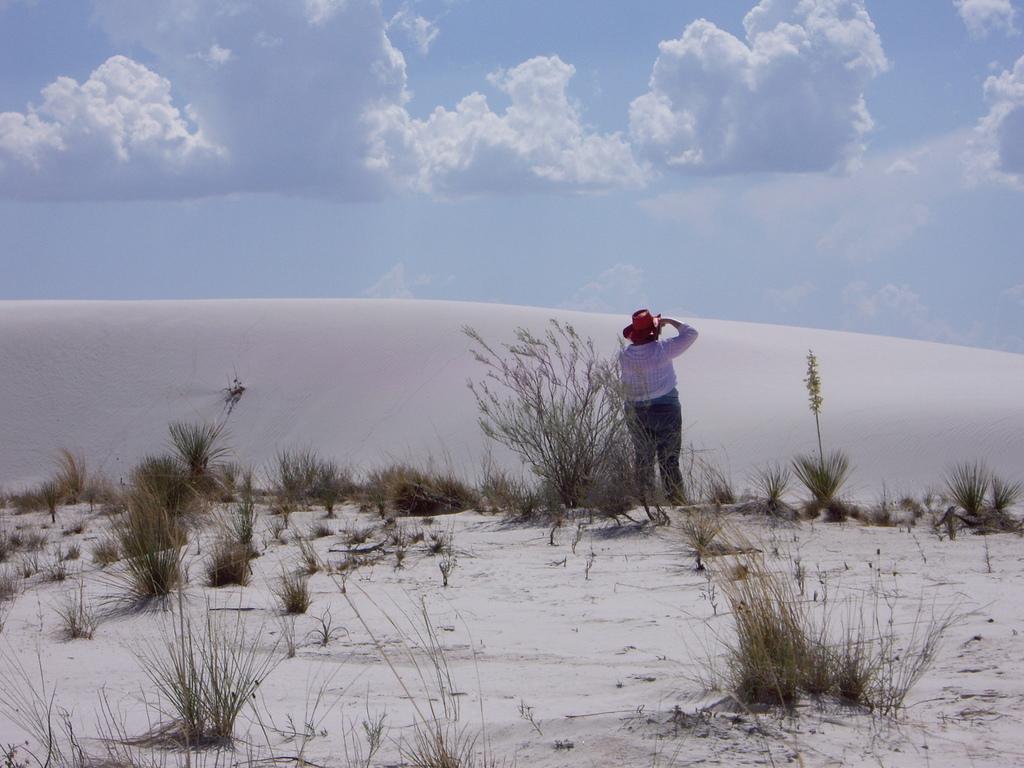Describe this image in one or two sentences. On the left side, there are plants and grass on the sand surface. On the right side, there is a person in a white color T-shirt, standing on the ground, on which there are plants and grass on the sand surface, there is a sand hill and there are clouds in the blue sky. 